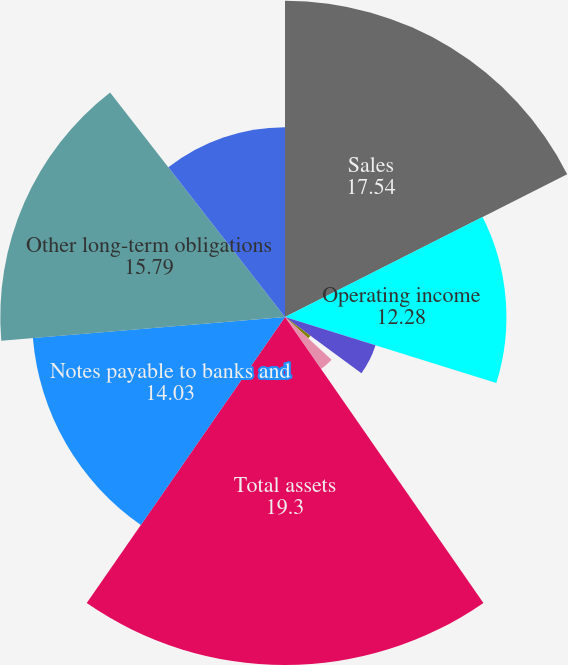Convert chart. <chart><loc_0><loc_0><loc_500><loc_500><pie_chart><fcel>Sales<fcel>Operating income<fcel>Net earnings (loss)<fcel>Basic earnings per share<fcel>Diluted earnings per share<fcel>Cash dividends declared per<fcel>Total assets<fcel>Notes payable to banks and<fcel>Other long-term obligations<fcel>Net cash provided by operating<nl><fcel>17.54%<fcel>12.28%<fcel>5.26%<fcel>0.0%<fcel>1.75%<fcel>3.51%<fcel>19.3%<fcel>14.03%<fcel>15.79%<fcel>10.53%<nl></chart> 